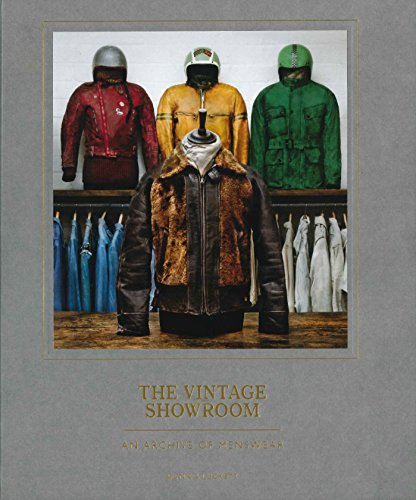Who wrote this book?
Answer the question using a single word or phrase. Douglas Gunn What is the title of this book? The Vintage Showroom: Vintage Menswear 2 What is the genre of this book? Health, Fitness & Dieting Is this a fitness book? Yes 